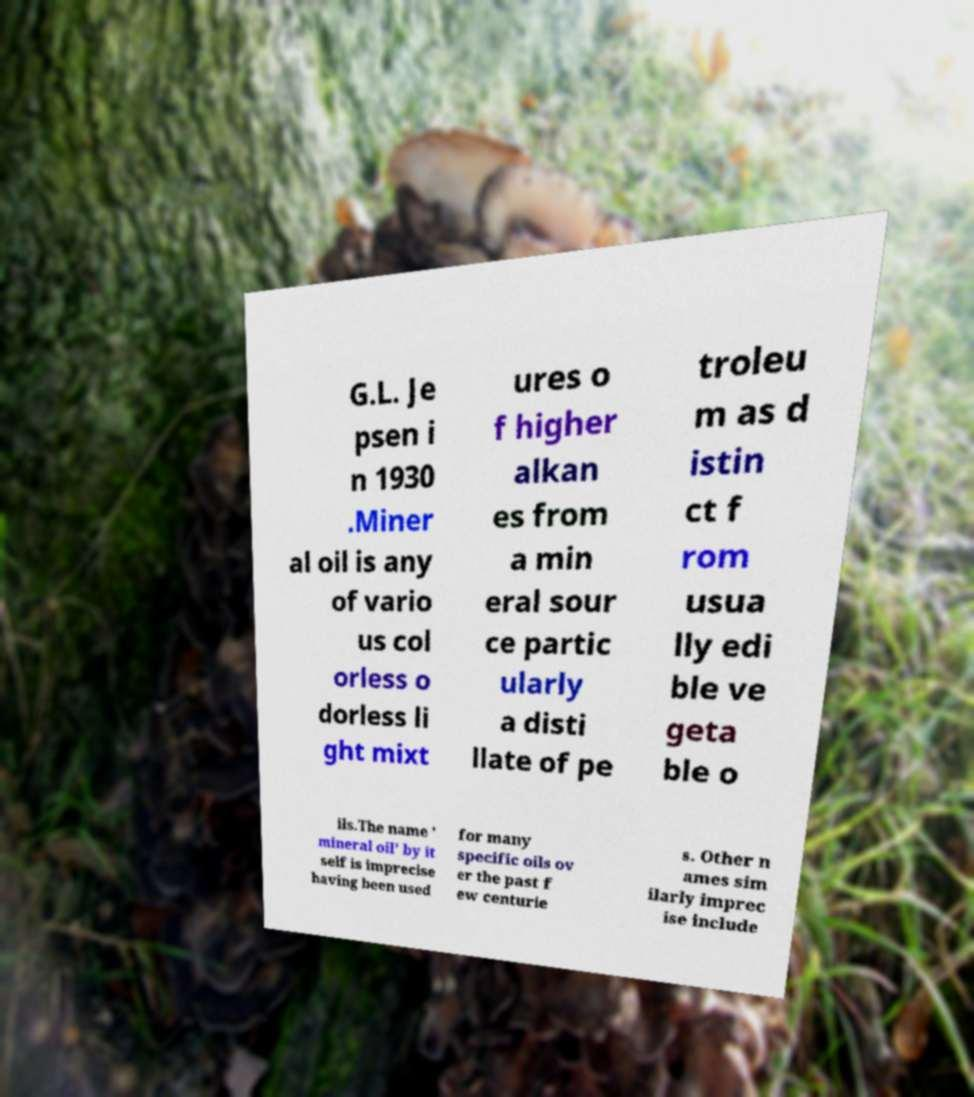Please identify and transcribe the text found in this image. G.L. Je psen i n 1930 .Miner al oil is any of vario us col orless o dorless li ght mixt ures o f higher alkan es from a min eral sour ce partic ularly a disti llate of pe troleu m as d istin ct f rom usua lly edi ble ve geta ble o ils.The name ' mineral oil' by it self is imprecise having been used for many specific oils ov er the past f ew centurie s. Other n ames sim ilarly imprec ise include 